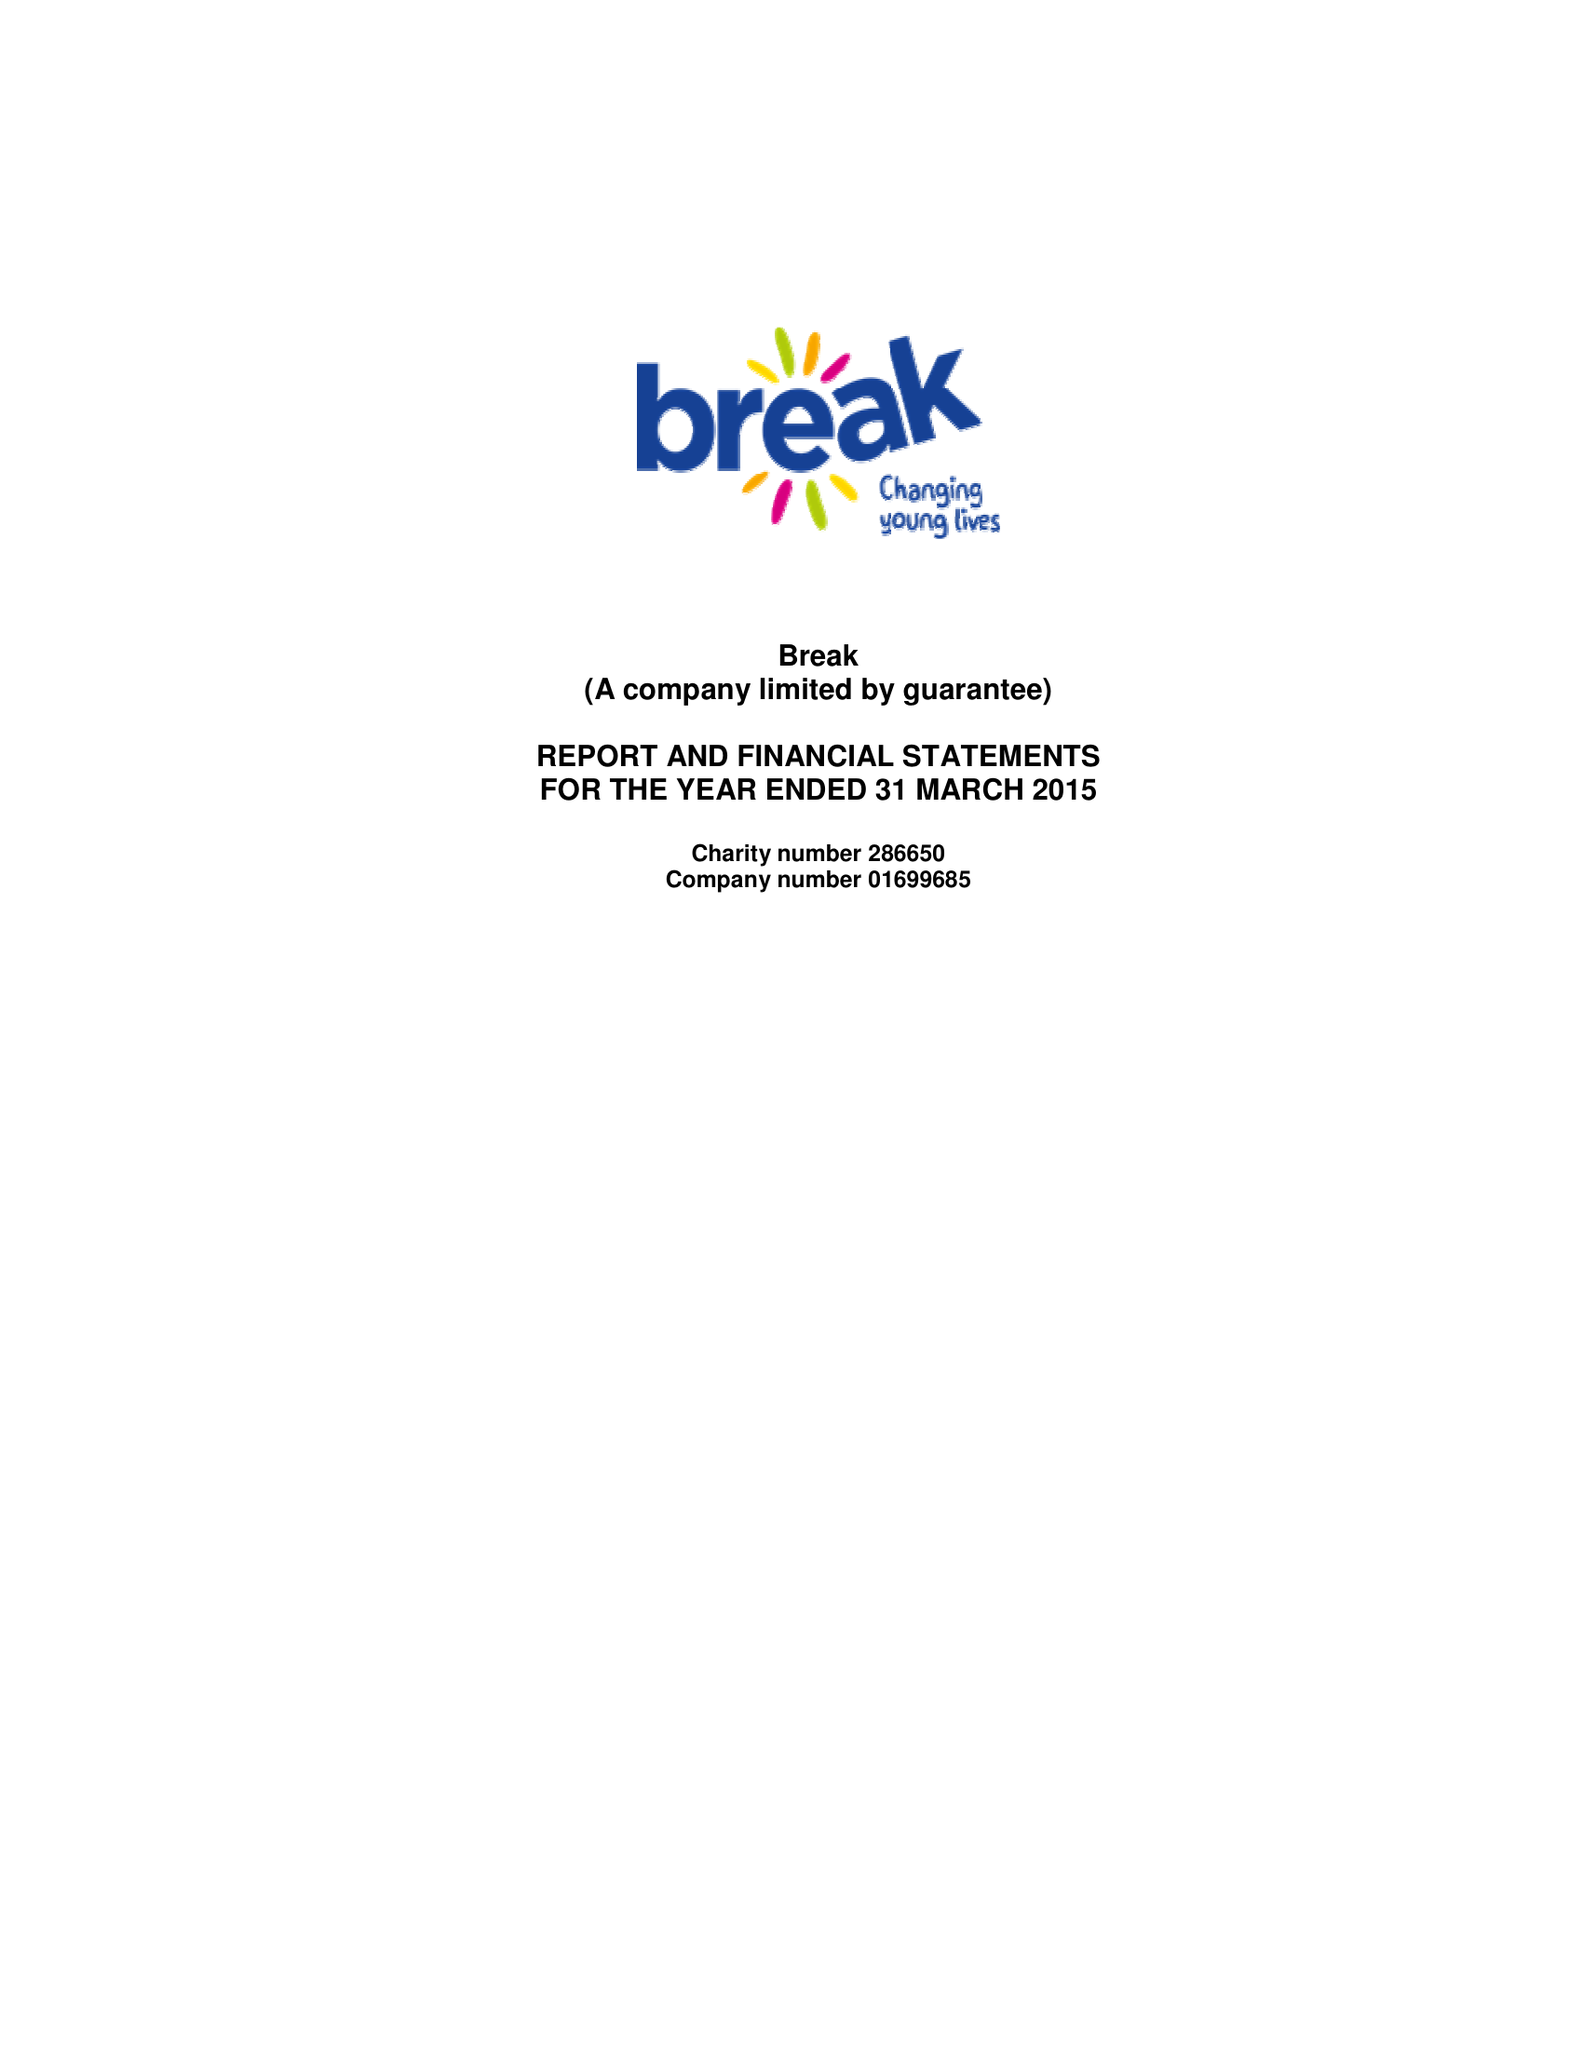What is the value for the address__street_line?
Answer the question using a single word or phrase. 1 SPAR ROAD 